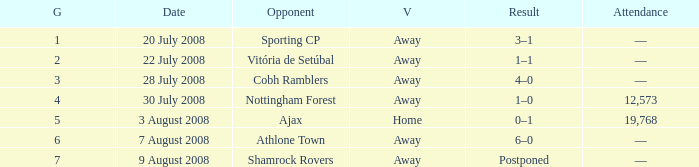What is the venue of game 3? Away. Would you mind parsing the complete table? {'header': ['G', 'Date', 'Opponent', 'V', 'Result', 'Attendance'], 'rows': [['1', '20 July 2008', 'Sporting CP', 'Away', '3–1', '—'], ['2', '22 July 2008', 'Vitória de Setúbal', 'Away', '1–1', '—'], ['3', '28 July 2008', 'Cobh Ramblers', 'Away', '4–0', '—'], ['4', '30 July 2008', 'Nottingham Forest', 'Away', '1–0', '12,573'], ['5', '3 August 2008', 'Ajax', 'Home', '0–1', '19,768'], ['6', '7 August 2008', 'Athlone Town', 'Away', '6–0', '—'], ['7', '9 August 2008', 'Shamrock Rovers', 'Away', 'Postponed', '—']]} 